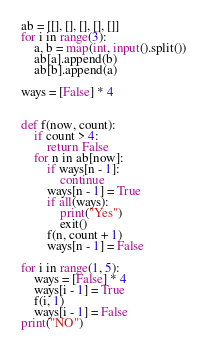Convert code to text. <code><loc_0><loc_0><loc_500><loc_500><_Python_>ab = [[], [], [], [], []]
for i in range(3):
    a, b = map(int, input().split())
    ab[a].append(b)
    ab[b].append(a)

ways = [False] * 4


def f(now, count):
    if count > 4:
        return False
    for n in ab[now]:
        if ways[n - 1]:
            continue
        ways[n - 1] = True
        if all(ways):
            print("Yes")
            exit()
        f(n, count + 1)
        ways[n - 1] = False

for i in range(1, 5):
    ways = [False] * 4
    ways[i - 1] = True
    f(i, 1)
    ways[i - 1] = False
print("NO")
</code> 